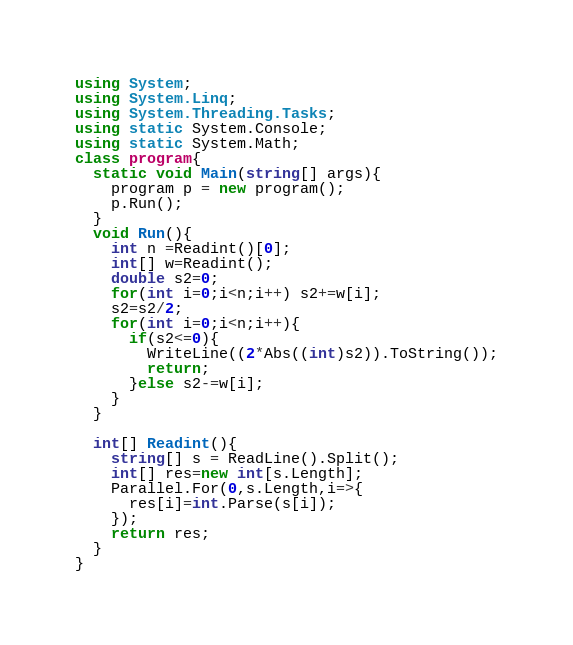<code> <loc_0><loc_0><loc_500><loc_500><_C#_>using System;
using System.Linq;
using System.Threading.Tasks;
using static System.Console;
using static System.Math;
class program{
  static void Main(string[] args){
    program p = new program();
    p.Run();
  }
  void Run(){
	int n =Readint()[0];
    int[] w=Readint();
    double s2=0;
    for(int i=0;i<n;i++) s2+=w[i];
    s2=s2/2;
    for(int i=0;i<n;i++){
      if(s2<=0){
        WriteLine((2*Abs((int)s2)).ToString());
        return;
      }else s2-=w[i];
    }
  }

  int[] Readint(){
    string[] s = ReadLine().Split();
    int[] res=new int[s.Length];
    Parallel.For(0,s.Length,i=>{
      res[i]=int.Parse(s[i]);
    });
    return res;
  }
}</code> 